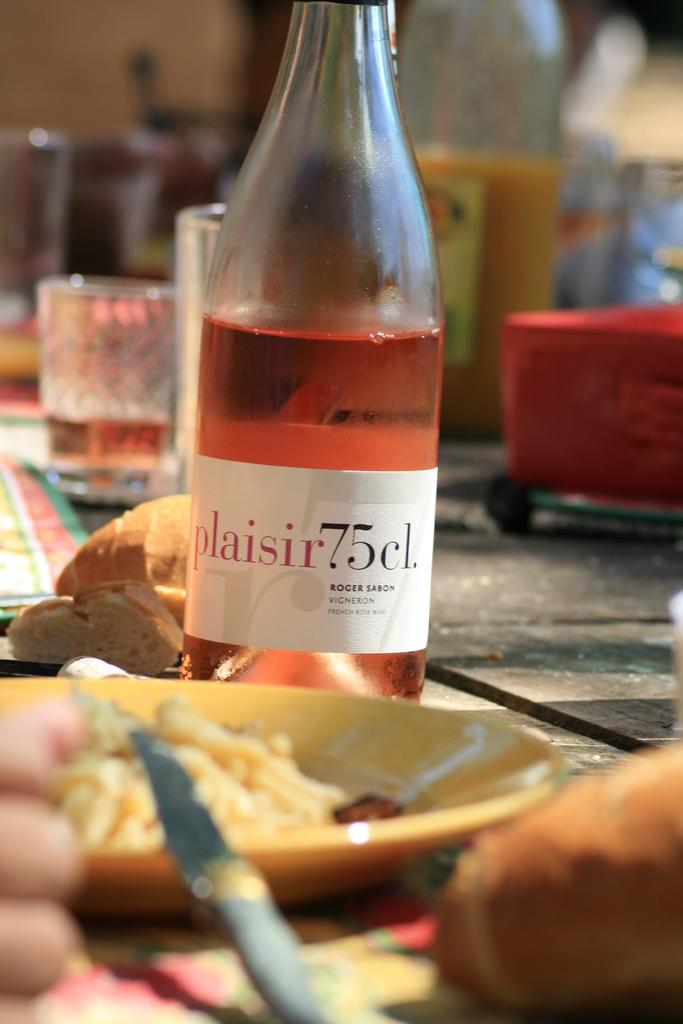<image>
Relay a brief, clear account of the picture shown. a bottle of Plaisir 75 cl wine on a table 